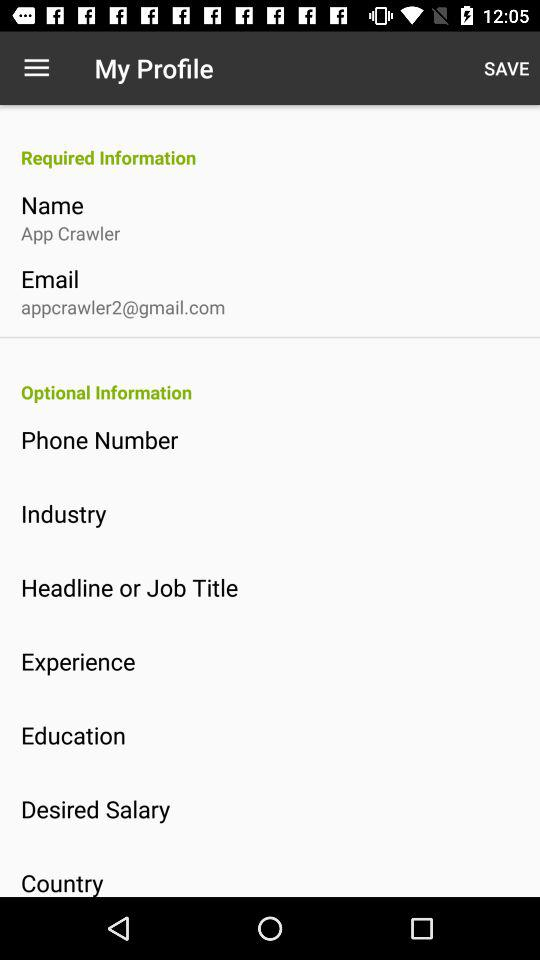How many required fields are there?
Answer the question using a single word or phrase. 2 